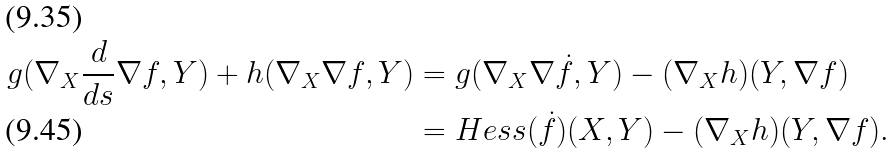Convert formula to latex. <formula><loc_0><loc_0><loc_500><loc_500>g ( \nabla _ { X } \frac { d } { d s } \nabla f , Y ) + h ( \nabla _ { X } \nabla f , Y ) & = g ( \nabla _ { X } \nabla \dot { f } , Y ) - ( \nabla _ { X } h ) ( Y , \nabla f ) \\ & = H e s s ( \dot { f } ) ( X , Y ) - ( \nabla _ { X } h ) ( Y , \nabla f ) .</formula> 